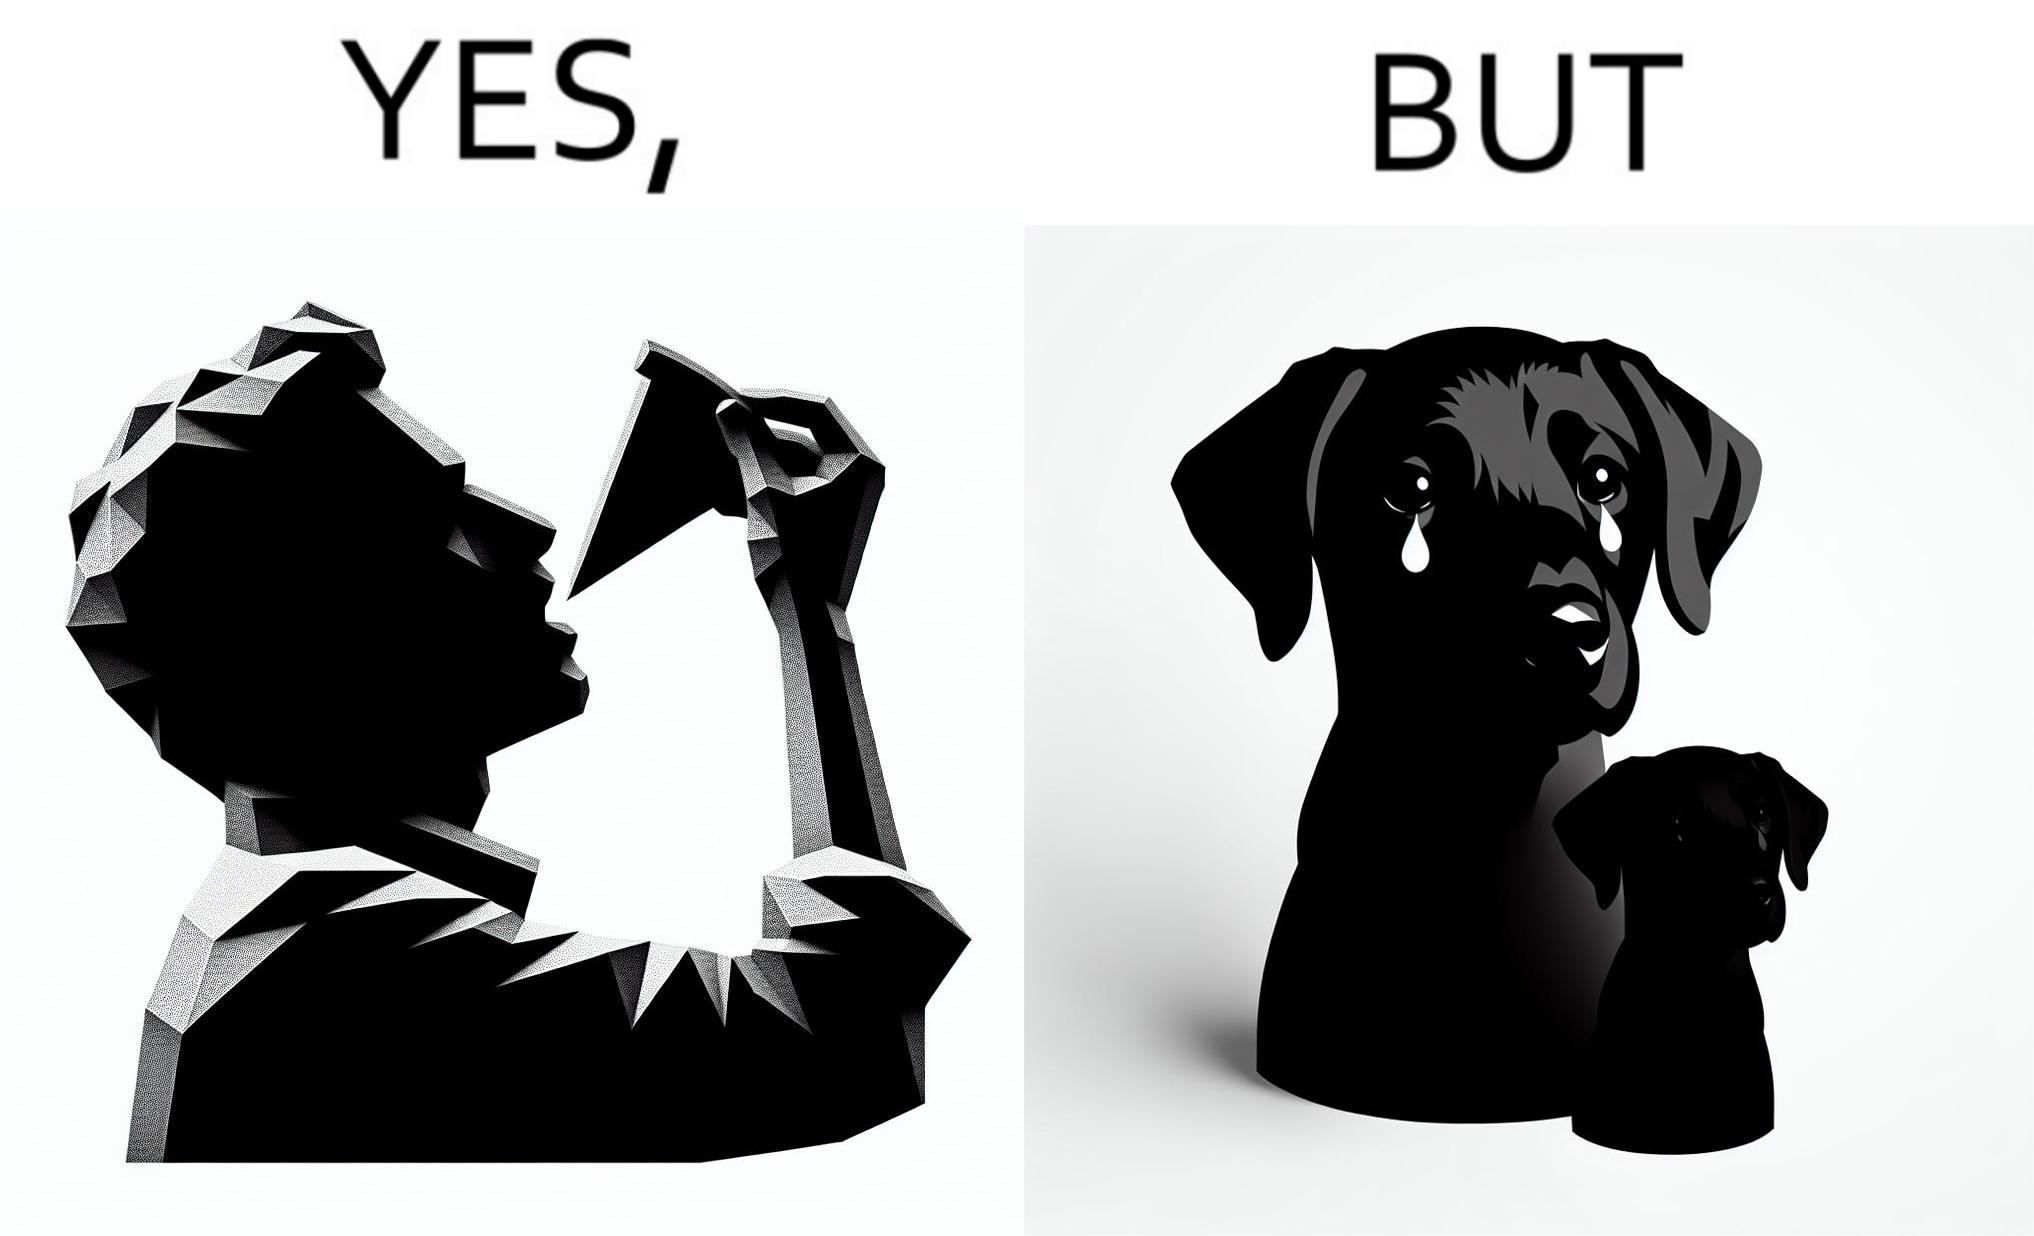What is shown in the left half versus the right half of this image? In the left part of the image: It is a man eating a pizza In the right part of the image: It is a pet dog with teary eyes 